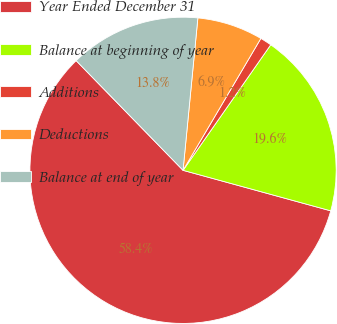<chart> <loc_0><loc_0><loc_500><loc_500><pie_chart><fcel>Year Ended December 31<fcel>Balance at beginning of year<fcel>Additions<fcel>Deductions<fcel>Balance at end of year<nl><fcel>58.45%<fcel>19.56%<fcel>1.22%<fcel>6.94%<fcel>13.84%<nl></chart> 